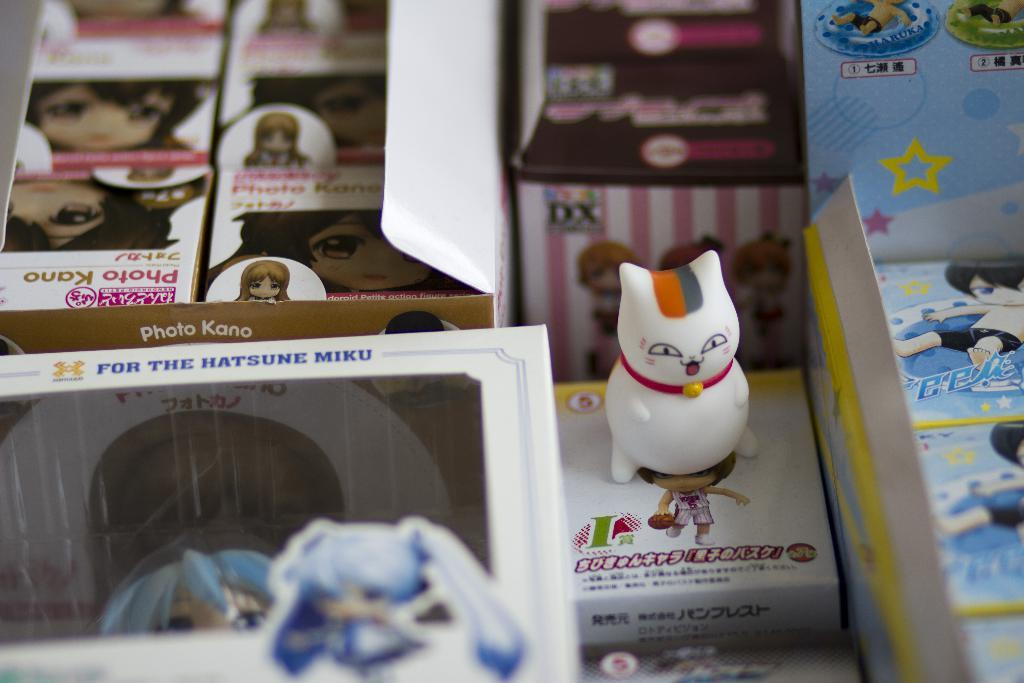<image>
Provide a brief description of the given image. a small cat figurine with the letter I next to it 